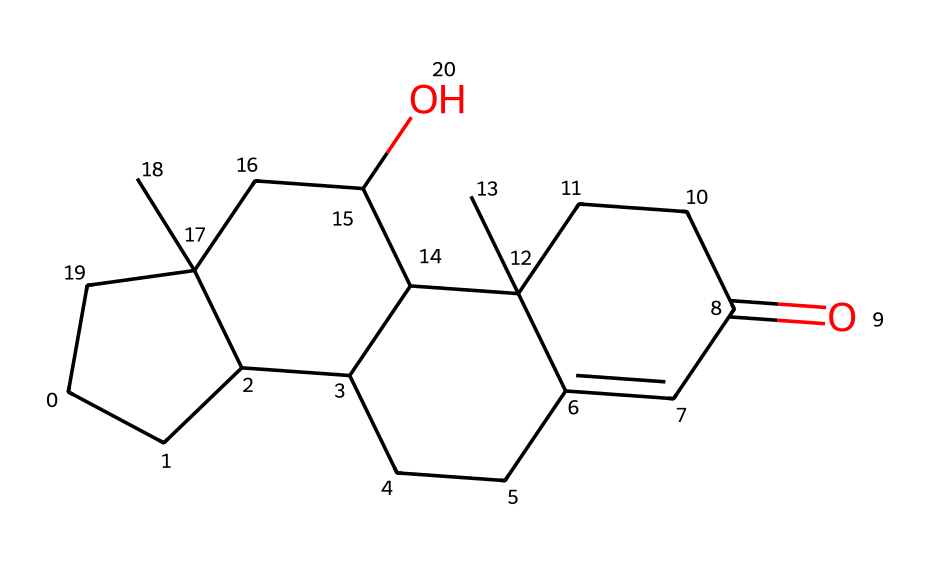What is the name of this chemical? The SMILES representation corresponds to the chemical structure of cortisol, a steroid hormone. The structural features indicate it is part of the corticosteroid family.
Answer: cortisol How many carbon atoms are present in this molecule? By analyzing the SMILES string, counting each "C" indicates a total of 21 carbon atoms in the structure.
Answer: 21 What type of functional group is present in this molecule? The SMILES shows the presence of a ketone functional group (indicated by "=O") attached to a cycloalkane structure, which is characteristic of cortisol.
Answer: ketone How many rings are present in the cycloalkane core of cortisol? By inspecting the structure, it is clear that there are four interconnected rings in its cycloalkane core, which is typical for many steroid hormones, including cortisol.
Answer: 4 What are the two main types of bonds found in this cycloalkane structure? The molecule contains single bonds (in saturated carbon chains) and a double bond (in the ketone functional group), typical characteristics of cycloalkanes.
Answer: single and double bonds Which part of this chemical is responsible for its solubility in lipids? The carbon-rich cyclic structure and the presence of hydrophobic alkyl groups contribute to its lipid solubility, a common trait in steroid hormones.
Answer: lipid solubility How does the cycloalkane structure impact cortisol's function in the body? The cycloalkane rings provide the steroid framework, allowing cortisol to interact effectively with its receptors, influencing immune responses and stress management.
Answer: steroid framework 